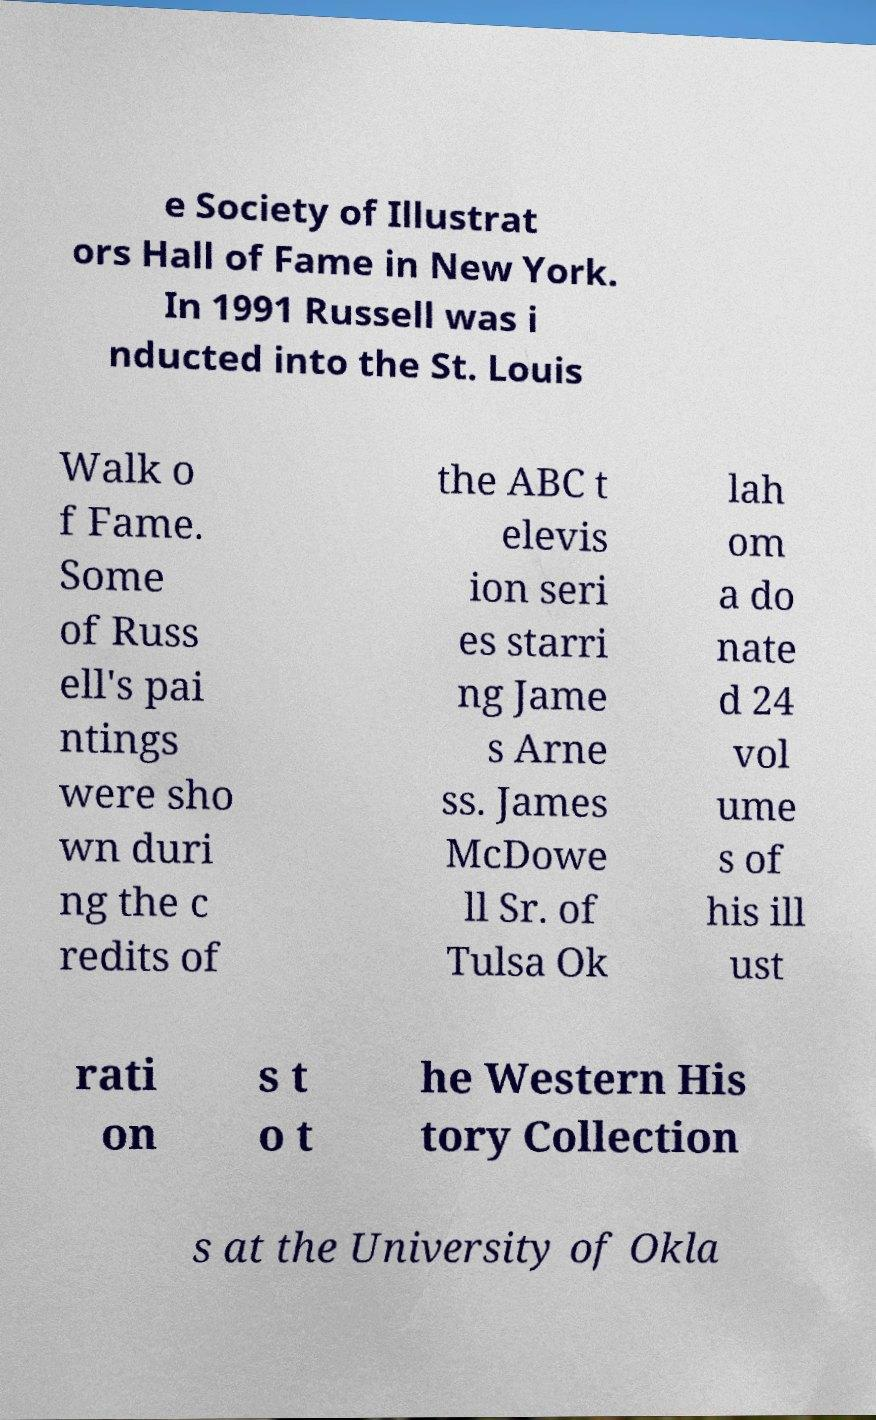For documentation purposes, I need the text within this image transcribed. Could you provide that? e Society of Illustrat ors Hall of Fame in New York. In 1991 Russell was i nducted into the St. Louis Walk o f Fame. Some of Russ ell's pai ntings were sho wn duri ng the c redits of the ABC t elevis ion seri es starri ng Jame s Arne ss. James McDowe ll Sr. of Tulsa Ok lah om a do nate d 24 vol ume s of his ill ust rati on s t o t he Western His tory Collection s at the University of Okla 